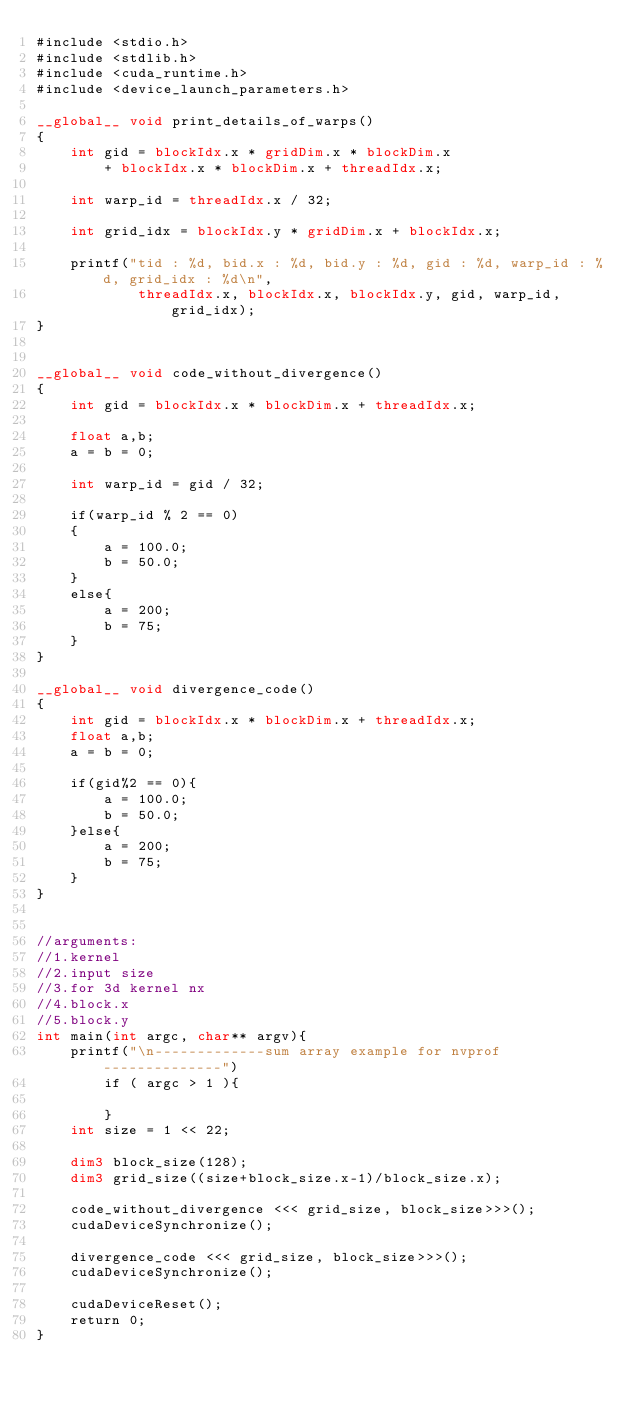<code> <loc_0><loc_0><loc_500><loc_500><_Cuda_>#include <stdio.h>
#include <stdlib.h>
#include <cuda_runtime.h>
#include <device_launch_parameters.h>

__global__ void print_details_of_warps()
{
    int gid = blockIdx.x * gridDim.x * blockDim.x
        + blockIdx.x * blockDim.x + threadIdx.x;

    int warp_id = threadIdx.x / 32;

    int grid_idx = blockIdx.y * gridDim.x + blockIdx.x;

    printf("tid : %d, bid.x : %d, bid.y : %d, gid : %d, warp_id : %d, grid_idx : %d\n",
            threadIdx.x, blockIdx.x, blockIdx.y, gid, warp_id, grid_idx);
}


__global__ void code_without_divergence()
{
    int gid = blockIdx.x * blockDim.x + threadIdx.x;

    float a,b;
    a = b = 0;

    int warp_id = gid / 32;

    if(warp_id % 2 == 0)
    {
        a = 100.0;
        b = 50.0;
    }
    else{
        a = 200;
        b = 75;
    }
}

__global__ void divergence_code()
{
    int gid = blockIdx.x * blockDim.x + threadIdx.x;
    float a,b;
    a = b = 0;

    if(gid%2 == 0){
        a = 100.0;
        b = 50.0;
    }else{
        a = 200;
        b = 75;
    }
}


//arguments:
//1.kernel
//2.input size
//3.for 3d kernel nx
//4.block.x
//5.block.y
int main(int argc, char** argv){
    printf("\n-------------sum array example for nvprof--------------")
        if ( argc > 1 ){

        }
    int size = 1 << 22;

    dim3 block_size(128);
    dim3 grid_size((size+block_size.x-1)/block_size.x);

    code_without_divergence <<< grid_size, block_size>>>();
    cudaDeviceSynchronize();

    divergence_code <<< grid_size, block_size>>>();
    cudaDeviceSynchronize();

    cudaDeviceReset();
    return 0;
}
</code> 